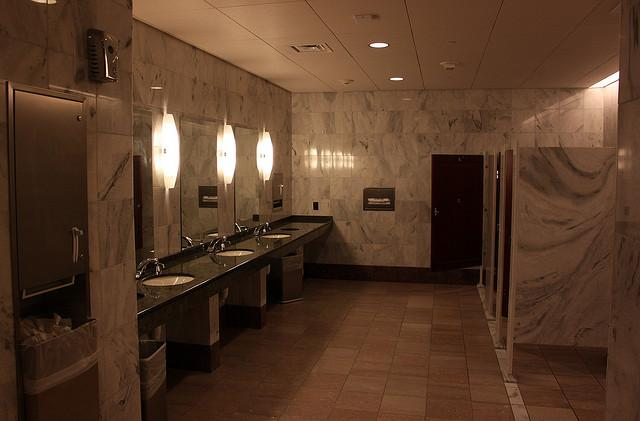What material is the tile for the walls and stalls of this bathroom? marble 